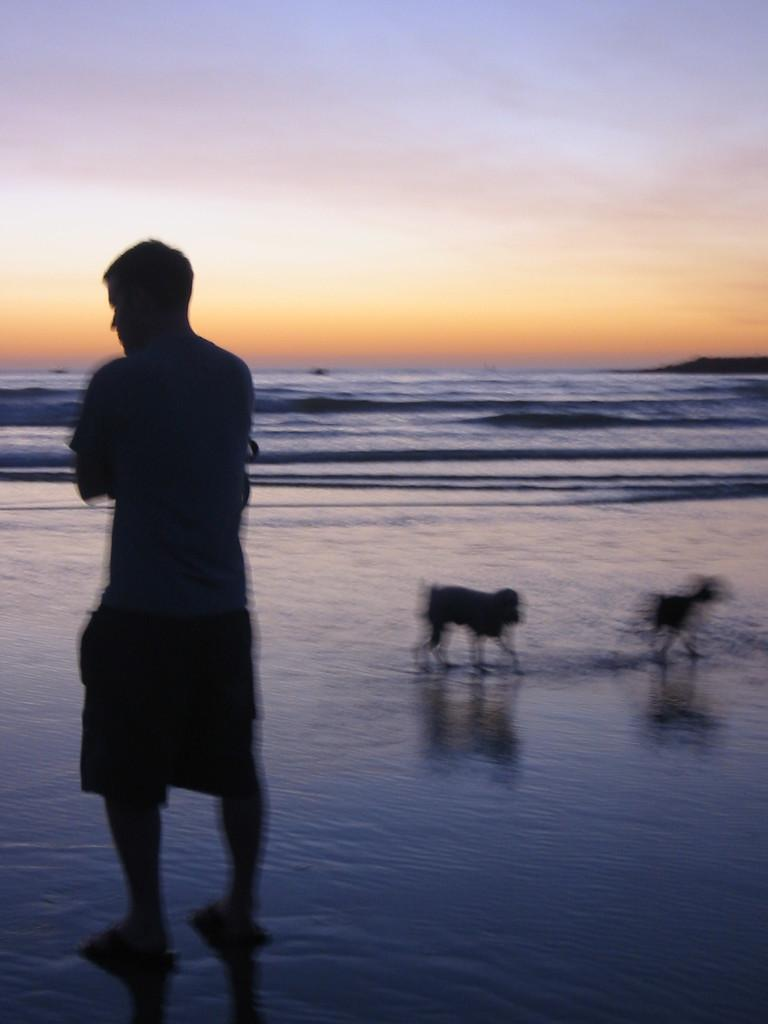Who or what is the main subject in the image? There is a person in the image. What else can be seen on the ground in the image? There are animals on the ground in the image. What can be seen in the distance in the image? There is water visible in the background of the image. What else is visible in the background of the image? The sky is visible in the background of the image. What type of substance is the manager using to govern the animals in the image? There is no manager or substance present in the image, and the animals are not being governed. 